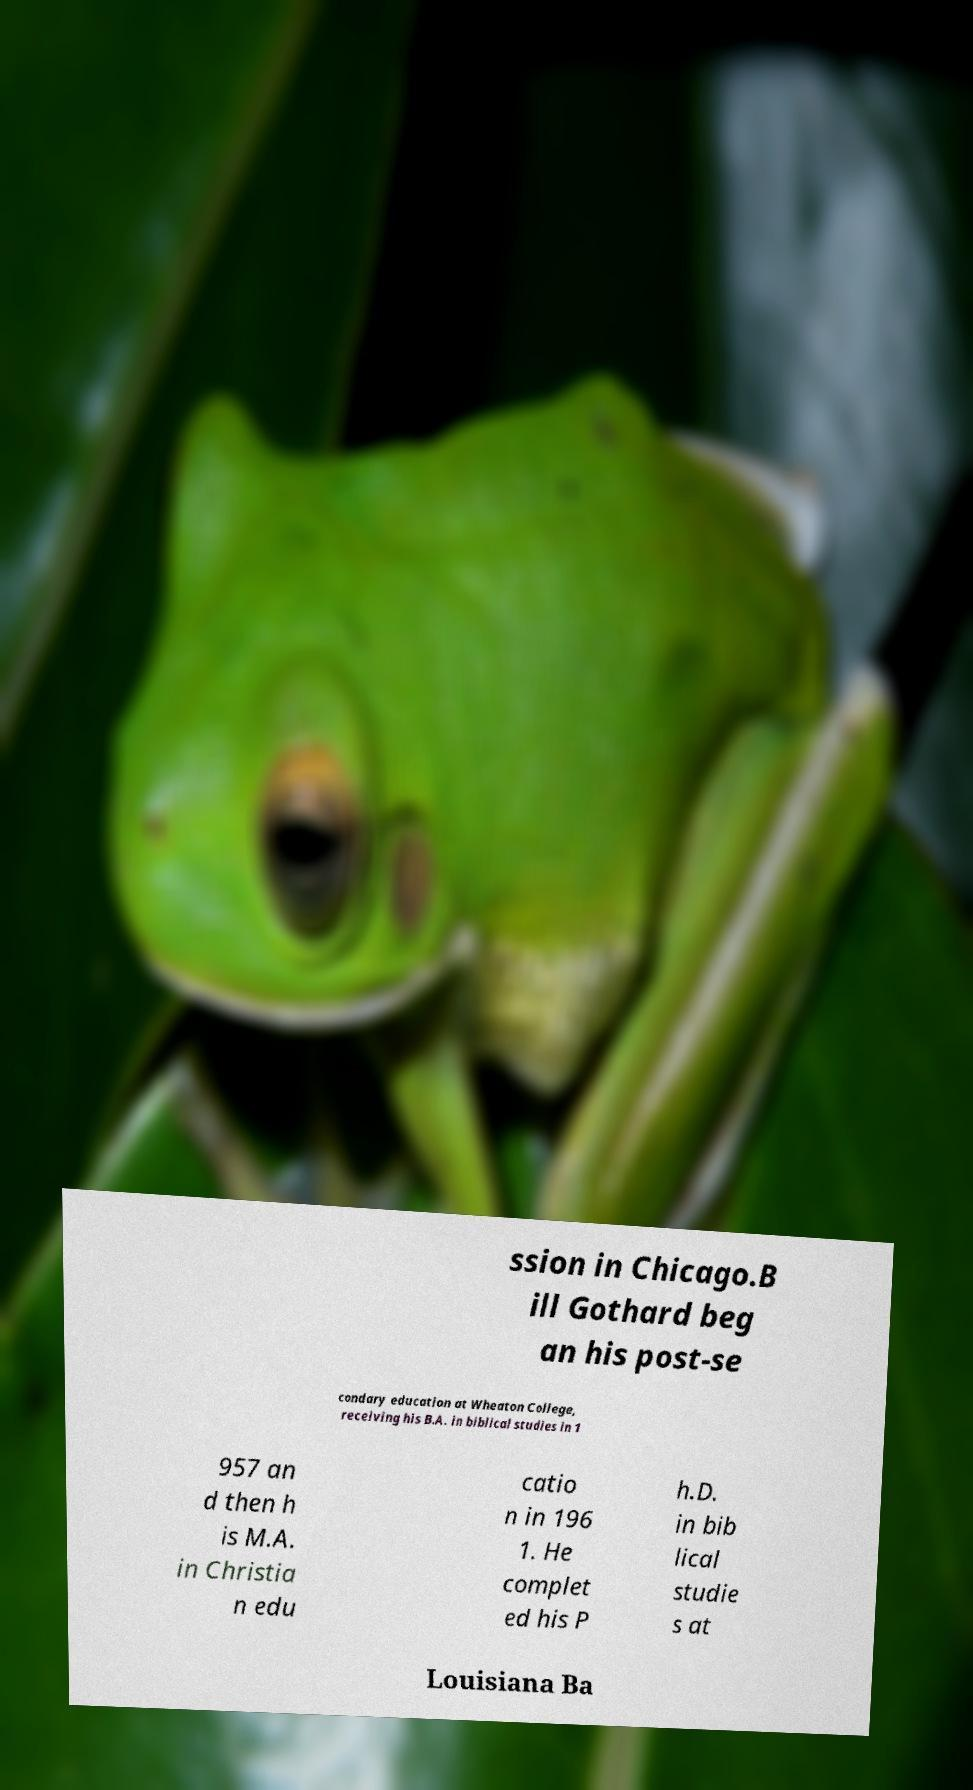Can you accurately transcribe the text from the provided image for me? ssion in Chicago.B ill Gothard beg an his post-se condary education at Wheaton College, receiving his B.A. in biblical studies in 1 957 an d then h is M.A. in Christia n edu catio n in 196 1. He complet ed his P h.D. in bib lical studie s at Louisiana Ba 